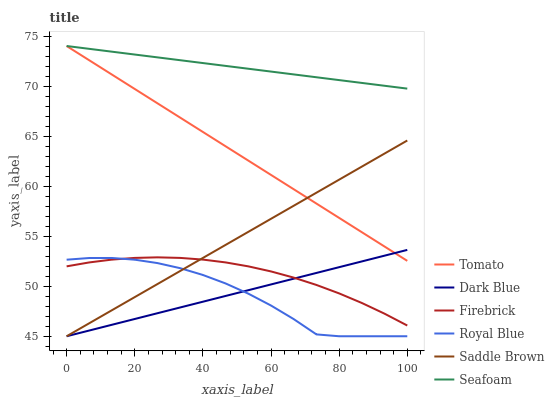Does Royal Blue have the minimum area under the curve?
Answer yes or no. Yes. Does Seafoam have the maximum area under the curve?
Answer yes or no. Yes. Does Firebrick have the minimum area under the curve?
Answer yes or no. No. Does Firebrick have the maximum area under the curve?
Answer yes or no. No. Is Dark Blue the smoothest?
Answer yes or no. Yes. Is Royal Blue the roughest?
Answer yes or no. Yes. Is Firebrick the smoothest?
Answer yes or no. No. Is Firebrick the roughest?
Answer yes or no. No. Does Royal Blue have the lowest value?
Answer yes or no. Yes. Does Firebrick have the lowest value?
Answer yes or no. No. Does Seafoam have the highest value?
Answer yes or no. Yes. Does Firebrick have the highest value?
Answer yes or no. No. Is Saddle Brown less than Seafoam?
Answer yes or no. Yes. Is Seafoam greater than Dark Blue?
Answer yes or no. Yes. Does Dark Blue intersect Saddle Brown?
Answer yes or no. Yes. Is Dark Blue less than Saddle Brown?
Answer yes or no. No. Is Dark Blue greater than Saddle Brown?
Answer yes or no. No. Does Saddle Brown intersect Seafoam?
Answer yes or no. No. 